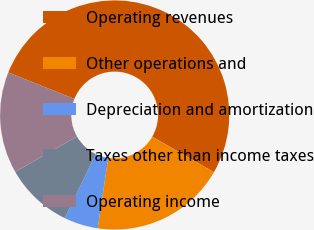<chart> <loc_0><loc_0><loc_500><loc_500><pie_chart><fcel>Operating revenues<fcel>Other operations and<fcel>Depreciation and amortization<fcel>Taxes other than income taxes<fcel>Operating income<nl><fcel>52.27%<fcel>19.05%<fcel>4.81%<fcel>9.56%<fcel>14.31%<nl></chart> 